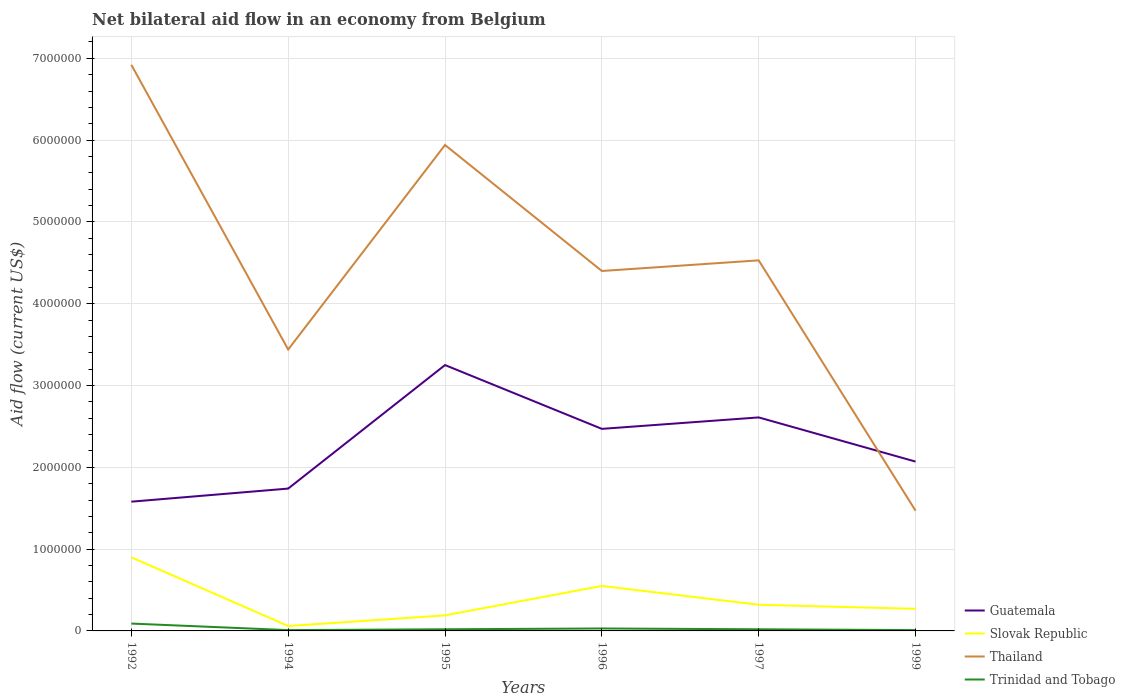How many different coloured lines are there?
Offer a very short reply. 4. Does the line corresponding to Thailand intersect with the line corresponding to Slovak Republic?
Ensure brevity in your answer.  No. Across all years, what is the maximum net bilateral aid flow in Guatemala?
Make the answer very short. 1.58e+06. What is the difference between the highest and the second highest net bilateral aid flow in Slovak Republic?
Your response must be concise. 8.40e+05. What is the difference between the highest and the lowest net bilateral aid flow in Slovak Republic?
Ensure brevity in your answer.  2. How many lines are there?
Your answer should be very brief. 4. How many years are there in the graph?
Provide a succinct answer. 6. What is the difference between two consecutive major ticks on the Y-axis?
Your response must be concise. 1.00e+06. Does the graph contain any zero values?
Your response must be concise. No. Does the graph contain grids?
Your answer should be very brief. Yes. How many legend labels are there?
Offer a very short reply. 4. What is the title of the graph?
Your answer should be very brief. Net bilateral aid flow in an economy from Belgium. What is the label or title of the Y-axis?
Provide a succinct answer. Aid flow (current US$). What is the Aid flow (current US$) of Guatemala in 1992?
Your answer should be very brief. 1.58e+06. What is the Aid flow (current US$) of Thailand in 1992?
Provide a short and direct response. 6.92e+06. What is the Aid flow (current US$) of Trinidad and Tobago in 1992?
Ensure brevity in your answer.  9.00e+04. What is the Aid flow (current US$) of Guatemala in 1994?
Offer a very short reply. 1.74e+06. What is the Aid flow (current US$) in Slovak Republic in 1994?
Ensure brevity in your answer.  6.00e+04. What is the Aid flow (current US$) in Thailand in 1994?
Offer a very short reply. 3.44e+06. What is the Aid flow (current US$) of Guatemala in 1995?
Provide a succinct answer. 3.25e+06. What is the Aid flow (current US$) in Thailand in 1995?
Offer a terse response. 5.94e+06. What is the Aid flow (current US$) of Trinidad and Tobago in 1995?
Make the answer very short. 2.00e+04. What is the Aid flow (current US$) in Guatemala in 1996?
Your response must be concise. 2.47e+06. What is the Aid flow (current US$) of Thailand in 1996?
Give a very brief answer. 4.40e+06. What is the Aid flow (current US$) of Guatemala in 1997?
Provide a succinct answer. 2.61e+06. What is the Aid flow (current US$) of Slovak Republic in 1997?
Ensure brevity in your answer.  3.20e+05. What is the Aid flow (current US$) in Thailand in 1997?
Make the answer very short. 4.53e+06. What is the Aid flow (current US$) of Guatemala in 1999?
Offer a terse response. 2.07e+06. What is the Aid flow (current US$) of Slovak Republic in 1999?
Offer a terse response. 2.70e+05. What is the Aid flow (current US$) in Thailand in 1999?
Your answer should be compact. 1.47e+06. What is the Aid flow (current US$) of Trinidad and Tobago in 1999?
Ensure brevity in your answer.  10000. Across all years, what is the maximum Aid flow (current US$) of Guatemala?
Keep it short and to the point. 3.25e+06. Across all years, what is the maximum Aid flow (current US$) of Slovak Republic?
Offer a terse response. 9.00e+05. Across all years, what is the maximum Aid flow (current US$) of Thailand?
Your answer should be compact. 6.92e+06. Across all years, what is the maximum Aid flow (current US$) in Trinidad and Tobago?
Offer a terse response. 9.00e+04. Across all years, what is the minimum Aid flow (current US$) in Guatemala?
Offer a very short reply. 1.58e+06. Across all years, what is the minimum Aid flow (current US$) in Slovak Republic?
Provide a succinct answer. 6.00e+04. Across all years, what is the minimum Aid flow (current US$) in Thailand?
Ensure brevity in your answer.  1.47e+06. What is the total Aid flow (current US$) in Guatemala in the graph?
Give a very brief answer. 1.37e+07. What is the total Aid flow (current US$) in Slovak Republic in the graph?
Make the answer very short. 2.29e+06. What is the total Aid flow (current US$) of Thailand in the graph?
Offer a terse response. 2.67e+07. What is the total Aid flow (current US$) in Trinidad and Tobago in the graph?
Offer a terse response. 1.80e+05. What is the difference between the Aid flow (current US$) in Guatemala in 1992 and that in 1994?
Your answer should be very brief. -1.60e+05. What is the difference between the Aid flow (current US$) of Slovak Republic in 1992 and that in 1994?
Provide a short and direct response. 8.40e+05. What is the difference between the Aid flow (current US$) in Thailand in 1992 and that in 1994?
Make the answer very short. 3.48e+06. What is the difference between the Aid flow (current US$) in Trinidad and Tobago in 1992 and that in 1994?
Your answer should be compact. 8.00e+04. What is the difference between the Aid flow (current US$) in Guatemala in 1992 and that in 1995?
Offer a very short reply. -1.67e+06. What is the difference between the Aid flow (current US$) in Slovak Republic in 1992 and that in 1995?
Offer a very short reply. 7.10e+05. What is the difference between the Aid flow (current US$) of Thailand in 1992 and that in 1995?
Keep it short and to the point. 9.80e+05. What is the difference between the Aid flow (current US$) in Guatemala in 1992 and that in 1996?
Ensure brevity in your answer.  -8.90e+05. What is the difference between the Aid flow (current US$) in Slovak Republic in 1992 and that in 1996?
Your answer should be very brief. 3.50e+05. What is the difference between the Aid flow (current US$) in Thailand in 1992 and that in 1996?
Ensure brevity in your answer.  2.52e+06. What is the difference between the Aid flow (current US$) of Guatemala in 1992 and that in 1997?
Offer a very short reply. -1.03e+06. What is the difference between the Aid flow (current US$) in Slovak Republic in 1992 and that in 1997?
Your response must be concise. 5.80e+05. What is the difference between the Aid flow (current US$) of Thailand in 1992 and that in 1997?
Offer a terse response. 2.39e+06. What is the difference between the Aid flow (current US$) in Trinidad and Tobago in 1992 and that in 1997?
Provide a succinct answer. 7.00e+04. What is the difference between the Aid flow (current US$) of Guatemala in 1992 and that in 1999?
Your response must be concise. -4.90e+05. What is the difference between the Aid flow (current US$) in Slovak Republic in 1992 and that in 1999?
Your response must be concise. 6.30e+05. What is the difference between the Aid flow (current US$) of Thailand in 1992 and that in 1999?
Make the answer very short. 5.45e+06. What is the difference between the Aid flow (current US$) in Guatemala in 1994 and that in 1995?
Make the answer very short. -1.51e+06. What is the difference between the Aid flow (current US$) in Thailand in 1994 and that in 1995?
Offer a very short reply. -2.50e+06. What is the difference between the Aid flow (current US$) in Guatemala in 1994 and that in 1996?
Your answer should be compact. -7.30e+05. What is the difference between the Aid flow (current US$) in Slovak Republic in 1994 and that in 1996?
Your response must be concise. -4.90e+05. What is the difference between the Aid flow (current US$) of Thailand in 1994 and that in 1996?
Give a very brief answer. -9.60e+05. What is the difference between the Aid flow (current US$) in Guatemala in 1994 and that in 1997?
Provide a succinct answer. -8.70e+05. What is the difference between the Aid flow (current US$) in Thailand in 1994 and that in 1997?
Give a very brief answer. -1.09e+06. What is the difference between the Aid flow (current US$) of Trinidad and Tobago in 1994 and that in 1997?
Keep it short and to the point. -10000. What is the difference between the Aid flow (current US$) of Guatemala in 1994 and that in 1999?
Keep it short and to the point. -3.30e+05. What is the difference between the Aid flow (current US$) in Slovak Republic in 1994 and that in 1999?
Provide a succinct answer. -2.10e+05. What is the difference between the Aid flow (current US$) of Thailand in 1994 and that in 1999?
Your answer should be compact. 1.97e+06. What is the difference between the Aid flow (current US$) in Trinidad and Tobago in 1994 and that in 1999?
Your answer should be compact. 0. What is the difference between the Aid flow (current US$) of Guatemala in 1995 and that in 1996?
Provide a short and direct response. 7.80e+05. What is the difference between the Aid flow (current US$) of Slovak Republic in 1995 and that in 1996?
Your answer should be very brief. -3.60e+05. What is the difference between the Aid flow (current US$) of Thailand in 1995 and that in 1996?
Your answer should be very brief. 1.54e+06. What is the difference between the Aid flow (current US$) of Guatemala in 1995 and that in 1997?
Provide a succinct answer. 6.40e+05. What is the difference between the Aid flow (current US$) of Thailand in 1995 and that in 1997?
Keep it short and to the point. 1.41e+06. What is the difference between the Aid flow (current US$) in Trinidad and Tobago in 1995 and that in 1997?
Your response must be concise. 0. What is the difference between the Aid flow (current US$) in Guatemala in 1995 and that in 1999?
Your answer should be very brief. 1.18e+06. What is the difference between the Aid flow (current US$) of Thailand in 1995 and that in 1999?
Provide a succinct answer. 4.47e+06. What is the difference between the Aid flow (current US$) in Guatemala in 1996 and that in 1997?
Give a very brief answer. -1.40e+05. What is the difference between the Aid flow (current US$) in Trinidad and Tobago in 1996 and that in 1997?
Your response must be concise. 10000. What is the difference between the Aid flow (current US$) in Guatemala in 1996 and that in 1999?
Provide a succinct answer. 4.00e+05. What is the difference between the Aid flow (current US$) of Slovak Republic in 1996 and that in 1999?
Provide a succinct answer. 2.80e+05. What is the difference between the Aid flow (current US$) of Thailand in 1996 and that in 1999?
Keep it short and to the point. 2.93e+06. What is the difference between the Aid flow (current US$) of Guatemala in 1997 and that in 1999?
Your answer should be very brief. 5.40e+05. What is the difference between the Aid flow (current US$) of Thailand in 1997 and that in 1999?
Provide a succinct answer. 3.06e+06. What is the difference between the Aid flow (current US$) of Guatemala in 1992 and the Aid flow (current US$) of Slovak Republic in 1994?
Your answer should be compact. 1.52e+06. What is the difference between the Aid flow (current US$) of Guatemala in 1992 and the Aid flow (current US$) of Thailand in 1994?
Make the answer very short. -1.86e+06. What is the difference between the Aid flow (current US$) of Guatemala in 1992 and the Aid flow (current US$) of Trinidad and Tobago in 1994?
Keep it short and to the point. 1.57e+06. What is the difference between the Aid flow (current US$) in Slovak Republic in 1992 and the Aid flow (current US$) in Thailand in 1994?
Keep it short and to the point. -2.54e+06. What is the difference between the Aid flow (current US$) of Slovak Republic in 1992 and the Aid flow (current US$) of Trinidad and Tobago in 1994?
Offer a terse response. 8.90e+05. What is the difference between the Aid flow (current US$) in Thailand in 1992 and the Aid flow (current US$) in Trinidad and Tobago in 1994?
Ensure brevity in your answer.  6.91e+06. What is the difference between the Aid flow (current US$) in Guatemala in 1992 and the Aid flow (current US$) in Slovak Republic in 1995?
Ensure brevity in your answer.  1.39e+06. What is the difference between the Aid flow (current US$) of Guatemala in 1992 and the Aid flow (current US$) of Thailand in 1995?
Keep it short and to the point. -4.36e+06. What is the difference between the Aid flow (current US$) of Guatemala in 1992 and the Aid flow (current US$) of Trinidad and Tobago in 1995?
Offer a very short reply. 1.56e+06. What is the difference between the Aid flow (current US$) of Slovak Republic in 1992 and the Aid flow (current US$) of Thailand in 1995?
Provide a succinct answer. -5.04e+06. What is the difference between the Aid flow (current US$) in Slovak Republic in 1992 and the Aid flow (current US$) in Trinidad and Tobago in 1995?
Provide a short and direct response. 8.80e+05. What is the difference between the Aid flow (current US$) of Thailand in 1992 and the Aid flow (current US$) of Trinidad and Tobago in 1995?
Offer a terse response. 6.90e+06. What is the difference between the Aid flow (current US$) in Guatemala in 1992 and the Aid flow (current US$) in Slovak Republic in 1996?
Provide a short and direct response. 1.03e+06. What is the difference between the Aid flow (current US$) of Guatemala in 1992 and the Aid flow (current US$) of Thailand in 1996?
Offer a very short reply. -2.82e+06. What is the difference between the Aid flow (current US$) of Guatemala in 1992 and the Aid flow (current US$) of Trinidad and Tobago in 1996?
Offer a terse response. 1.55e+06. What is the difference between the Aid flow (current US$) of Slovak Republic in 1992 and the Aid flow (current US$) of Thailand in 1996?
Your answer should be compact. -3.50e+06. What is the difference between the Aid flow (current US$) in Slovak Republic in 1992 and the Aid flow (current US$) in Trinidad and Tobago in 1996?
Your response must be concise. 8.70e+05. What is the difference between the Aid flow (current US$) in Thailand in 1992 and the Aid flow (current US$) in Trinidad and Tobago in 1996?
Your answer should be compact. 6.89e+06. What is the difference between the Aid flow (current US$) in Guatemala in 1992 and the Aid flow (current US$) in Slovak Republic in 1997?
Offer a very short reply. 1.26e+06. What is the difference between the Aid flow (current US$) of Guatemala in 1992 and the Aid flow (current US$) of Thailand in 1997?
Make the answer very short. -2.95e+06. What is the difference between the Aid flow (current US$) of Guatemala in 1992 and the Aid flow (current US$) of Trinidad and Tobago in 1997?
Make the answer very short. 1.56e+06. What is the difference between the Aid flow (current US$) of Slovak Republic in 1992 and the Aid flow (current US$) of Thailand in 1997?
Offer a terse response. -3.63e+06. What is the difference between the Aid flow (current US$) of Slovak Republic in 1992 and the Aid flow (current US$) of Trinidad and Tobago in 1997?
Keep it short and to the point. 8.80e+05. What is the difference between the Aid flow (current US$) in Thailand in 1992 and the Aid flow (current US$) in Trinidad and Tobago in 1997?
Provide a succinct answer. 6.90e+06. What is the difference between the Aid flow (current US$) of Guatemala in 1992 and the Aid flow (current US$) of Slovak Republic in 1999?
Your answer should be compact. 1.31e+06. What is the difference between the Aid flow (current US$) of Guatemala in 1992 and the Aid flow (current US$) of Thailand in 1999?
Offer a terse response. 1.10e+05. What is the difference between the Aid flow (current US$) of Guatemala in 1992 and the Aid flow (current US$) of Trinidad and Tobago in 1999?
Offer a very short reply. 1.57e+06. What is the difference between the Aid flow (current US$) of Slovak Republic in 1992 and the Aid flow (current US$) of Thailand in 1999?
Provide a short and direct response. -5.70e+05. What is the difference between the Aid flow (current US$) in Slovak Republic in 1992 and the Aid flow (current US$) in Trinidad and Tobago in 1999?
Your response must be concise. 8.90e+05. What is the difference between the Aid flow (current US$) in Thailand in 1992 and the Aid flow (current US$) in Trinidad and Tobago in 1999?
Your answer should be compact. 6.91e+06. What is the difference between the Aid flow (current US$) in Guatemala in 1994 and the Aid flow (current US$) in Slovak Republic in 1995?
Your answer should be compact. 1.55e+06. What is the difference between the Aid flow (current US$) in Guatemala in 1994 and the Aid flow (current US$) in Thailand in 1995?
Your answer should be compact. -4.20e+06. What is the difference between the Aid flow (current US$) in Guatemala in 1994 and the Aid flow (current US$) in Trinidad and Tobago in 1995?
Make the answer very short. 1.72e+06. What is the difference between the Aid flow (current US$) in Slovak Republic in 1994 and the Aid flow (current US$) in Thailand in 1995?
Provide a succinct answer. -5.88e+06. What is the difference between the Aid flow (current US$) in Slovak Republic in 1994 and the Aid flow (current US$) in Trinidad and Tobago in 1995?
Offer a very short reply. 4.00e+04. What is the difference between the Aid flow (current US$) of Thailand in 1994 and the Aid flow (current US$) of Trinidad and Tobago in 1995?
Provide a short and direct response. 3.42e+06. What is the difference between the Aid flow (current US$) in Guatemala in 1994 and the Aid flow (current US$) in Slovak Republic in 1996?
Your response must be concise. 1.19e+06. What is the difference between the Aid flow (current US$) of Guatemala in 1994 and the Aid flow (current US$) of Thailand in 1996?
Provide a short and direct response. -2.66e+06. What is the difference between the Aid flow (current US$) of Guatemala in 1994 and the Aid flow (current US$) of Trinidad and Tobago in 1996?
Offer a very short reply. 1.71e+06. What is the difference between the Aid flow (current US$) of Slovak Republic in 1994 and the Aid flow (current US$) of Thailand in 1996?
Make the answer very short. -4.34e+06. What is the difference between the Aid flow (current US$) of Slovak Republic in 1994 and the Aid flow (current US$) of Trinidad and Tobago in 1996?
Keep it short and to the point. 3.00e+04. What is the difference between the Aid flow (current US$) of Thailand in 1994 and the Aid flow (current US$) of Trinidad and Tobago in 1996?
Keep it short and to the point. 3.41e+06. What is the difference between the Aid flow (current US$) of Guatemala in 1994 and the Aid flow (current US$) of Slovak Republic in 1997?
Keep it short and to the point. 1.42e+06. What is the difference between the Aid flow (current US$) in Guatemala in 1994 and the Aid flow (current US$) in Thailand in 1997?
Your response must be concise. -2.79e+06. What is the difference between the Aid flow (current US$) of Guatemala in 1994 and the Aid flow (current US$) of Trinidad and Tobago in 1997?
Ensure brevity in your answer.  1.72e+06. What is the difference between the Aid flow (current US$) of Slovak Republic in 1994 and the Aid flow (current US$) of Thailand in 1997?
Make the answer very short. -4.47e+06. What is the difference between the Aid flow (current US$) in Slovak Republic in 1994 and the Aid flow (current US$) in Trinidad and Tobago in 1997?
Ensure brevity in your answer.  4.00e+04. What is the difference between the Aid flow (current US$) in Thailand in 1994 and the Aid flow (current US$) in Trinidad and Tobago in 1997?
Provide a succinct answer. 3.42e+06. What is the difference between the Aid flow (current US$) in Guatemala in 1994 and the Aid flow (current US$) in Slovak Republic in 1999?
Ensure brevity in your answer.  1.47e+06. What is the difference between the Aid flow (current US$) of Guatemala in 1994 and the Aid flow (current US$) of Thailand in 1999?
Your answer should be compact. 2.70e+05. What is the difference between the Aid flow (current US$) in Guatemala in 1994 and the Aid flow (current US$) in Trinidad and Tobago in 1999?
Give a very brief answer. 1.73e+06. What is the difference between the Aid flow (current US$) in Slovak Republic in 1994 and the Aid flow (current US$) in Thailand in 1999?
Make the answer very short. -1.41e+06. What is the difference between the Aid flow (current US$) of Slovak Republic in 1994 and the Aid flow (current US$) of Trinidad and Tobago in 1999?
Your answer should be very brief. 5.00e+04. What is the difference between the Aid flow (current US$) in Thailand in 1994 and the Aid flow (current US$) in Trinidad and Tobago in 1999?
Provide a short and direct response. 3.43e+06. What is the difference between the Aid flow (current US$) of Guatemala in 1995 and the Aid flow (current US$) of Slovak Republic in 1996?
Give a very brief answer. 2.70e+06. What is the difference between the Aid flow (current US$) in Guatemala in 1995 and the Aid flow (current US$) in Thailand in 1996?
Give a very brief answer. -1.15e+06. What is the difference between the Aid flow (current US$) in Guatemala in 1995 and the Aid flow (current US$) in Trinidad and Tobago in 1996?
Ensure brevity in your answer.  3.22e+06. What is the difference between the Aid flow (current US$) of Slovak Republic in 1995 and the Aid flow (current US$) of Thailand in 1996?
Your answer should be compact. -4.21e+06. What is the difference between the Aid flow (current US$) in Slovak Republic in 1995 and the Aid flow (current US$) in Trinidad and Tobago in 1996?
Provide a succinct answer. 1.60e+05. What is the difference between the Aid flow (current US$) in Thailand in 1995 and the Aid flow (current US$) in Trinidad and Tobago in 1996?
Offer a terse response. 5.91e+06. What is the difference between the Aid flow (current US$) of Guatemala in 1995 and the Aid flow (current US$) of Slovak Republic in 1997?
Keep it short and to the point. 2.93e+06. What is the difference between the Aid flow (current US$) of Guatemala in 1995 and the Aid flow (current US$) of Thailand in 1997?
Your response must be concise. -1.28e+06. What is the difference between the Aid flow (current US$) of Guatemala in 1995 and the Aid flow (current US$) of Trinidad and Tobago in 1997?
Give a very brief answer. 3.23e+06. What is the difference between the Aid flow (current US$) of Slovak Republic in 1995 and the Aid flow (current US$) of Thailand in 1997?
Offer a very short reply. -4.34e+06. What is the difference between the Aid flow (current US$) in Slovak Republic in 1995 and the Aid flow (current US$) in Trinidad and Tobago in 1997?
Make the answer very short. 1.70e+05. What is the difference between the Aid flow (current US$) of Thailand in 1995 and the Aid flow (current US$) of Trinidad and Tobago in 1997?
Your response must be concise. 5.92e+06. What is the difference between the Aid flow (current US$) in Guatemala in 1995 and the Aid flow (current US$) in Slovak Republic in 1999?
Your answer should be compact. 2.98e+06. What is the difference between the Aid flow (current US$) in Guatemala in 1995 and the Aid flow (current US$) in Thailand in 1999?
Provide a short and direct response. 1.78e+06. What is the difference between the Aid flow (current US$) in Guatemala in 1995 and the Aid flow (current US$) in Trinidad and Tobago in 1999?
Offer a terse response. 3.24e+06. What is the difference between the Aid flow (current US$) of Slovak Republic in 1995 and the Aid flow (current US$) of Thailand in 1999?
Offer a terse response. -1.28e+06. What is the difference between the Aid flow (current US$) in Thailand in 1995 and the Aid flow (current US$) in Trinidad and Tobago in 1999?
Offer a terse response. 5.93e+06. What is the difference between the Aid flow (current US$) in Guatemala in 1996 and the Aid flow (current US$) in Slovak Republic in 1997?
Provide a short and direct response. 2.15e+06. What is the difference between the Aid flow (current US$) of Guatemala in 1996 and the Aid flow (current US$) of Thailand in 1997?
Offer a terse response. -2.06e+06. What is the difference between the Aid flow (current US$) in Guatemala in 1996 and the Aid flow (current US$) in Trinidad and Tobago in 1997?
Make the answer very short. 2.45e+06. What is the difference between the Aid flow (current US$) of Slovak Republic in 1996 and the Aid flow (current US$) of Thailand in 1997?
Your answer should be very brief. -3.98e+06. What is the difference between the Aid flow (current US$) of Slovak Republic in 1996 and the Aid flow (current US$) of Trinidad and Tobago in 1997?
Your answer should be very brief. 5.30e+05. What is the difference between the Aid flow (current US$) in Thailand in 1996 and the Aid flow (current US$) in Trinidad and Tobago in 1997?
Make the answer very short. 4.38e+06. What is the difference between the Aid flow (current US$) in Guatemala in 1996 and the Aid flow (current US$) in Slovak Republic in 1999?
Your answer should be very brief. 2.20e+06. What is the difference between the Aid flow (current US$) in Guatemala in 1996 and the Aid flow (current US$) in Trinidad and Tobago in 1999?
Provide a short and direct response. 2.46e+06. What is the difference between the Aid flow (current US$) in Slovak Republic in 1996 and the Aid flow (current US$) in Thailand in 1999?
Keep it short and to the point. -9.20e+05. What is the difference between the Aid flow (current US$) of Slovak Republic in 1996 and the Aid flow (current US$) of Trinidad and Tobago in 1999?
Keep it short and to the point. 5.40e+05. What is the difference between the Aid flow (current US$) of Thailand in 1996 and the Aid flow (current US$) of Trinidad and Tobago in 1999?
Make the answer very short. 4.39e+06. What is the difference between the Aid flow (current US$) in Guatemala in 1997 and the Aid flow (current US$) in Slovak Republic in 1999?
Your answer should be compact. 2.34e+06. What is the difference between the Aid flow (current US$) in Guatemala in 1997 and the Aid flow (current US$) in Thailand in 1999?
Ensure brevity in your answer.  1.14e+06. What is the difference between the Aid flow (current US$) of Guatemala in 1997 and the Aid flow (current US$) of Trinidad and Tobago in 1999?
Offer a terse response. 2.60e+06. What is the difference between the Aid flow (current US$) of Slovak Republic in 1997 and the Aid flow (current US$) of Thailand in 1999?
Give a very brief answer. -1.15e+06. What is the difference between the Aid flow (current US$) of Thailand in 1997 and the Aid flow (current US$) of Trinidad and Tobago in 1999?
Make the answer very short. 4.52e+06. What is the average Aid flow (current US$) in Guatemala per year?
Your answer should be compact. 2.29e+06. What is the average Aid flow (current US$) of Slovak Republic per year?
Your answer should be compact. 3.82e+05. What is the average Aid flow (current US$) of Thailand per year?
Your answer should be compact. 4.45e+06. In the year 1992, what is the difference between the Aid flow (current US$) in Guatemala and Aid flow (current US$) in Slovak Republic?
Your answer should be compact. 6.80e+05. In the year 1992, what is the difference between the Aid flow (current US$) in Guatemala and Aid flow (current US$) in Thailand?
Keep it short and to the point. -5.34e+06. In the year 1992, what is the difference between the Aid flow (current US$) of Guatemala and Aid flow (current US$) of Trinidad and Tobago?
Make the answer very short. 1.49e+06. In the year 1992, what is the difference between the Aid flow (current US$) in Slovak Republic and Aid flow (current US$) in Thailand?
Offer a very short reply. -6.02e+06. In the year 1992, what is the difference between the Aid flow (current US$) in Slovak Republic and Aid flow (current US$) in Trinidad and Tobago?
Offer a terse response. 8.10e+05. In the year 1992, what is the difference between the Aid flow (current US$) of Thailand and Aid flow (current US$) of Trinidad and Tobago?
Your answer should be very brief. 6.83e+06. In the year 1994, what is the difference between the Aid flow (current US$) of Guatemala and Aid flow (current US$) of Slovak Republic?
Your answer should be very brief. 1.68e+06. In the year 1994, what is the difference between the Aid flow (current US$) of Guatemala and Aid flow (current US$) of Thailand?
Provide a short and direct response. -1.70e+06. In the year 1994, what is the difference between the Aid flow (current US$) in Guatemala and Aid flow (current US$) in Trinidad and Tobago?
Make the answer very short. 1.73e+06. In the year 1994, what is the difference between the Aid flow (current US$) in Slovak Republic and Aid flow (current US$) in Thailand?
Your response must be concise. -3.38e+06. In the year 1994, what is the difference between the Aid flow (current US$) in Slovak Republic and Aid flow (current US$) in Trinidad and Tobago?
Ensure brevity in your answer.  5.00e+04. In the year 1994, what is the difference between the Aid flow (current US$) in Thailand and Aid flow (current US$) in Trinidad and Tobago?
Provide a short and direct response. 3.43e+06. In the year 1995, what is the difference between the Aid flow (current US$) in Guatemala and Aid flow (current US$) in Slovak Republic?
Provide a succinct answer. 3.06e+06. In the year 1995, what is the difference between the Aid flow (current US$) in Guatemala and Aid flow (current US$) in Thailand?
Offer a very short reply. -2.69e+06. In the year 1995, what is the difference between the Aid flow (current US$) of Guatemala and Aid flow (current US$) of Trinidad and Tobago?
Offer a terse response. 3.23e+06. In the year 1995, what is the difference between the Aid flow (current US$) in Slovak Republic and Aid flow (current US$) in Thailand?
Keep it short and to the point. -5.75e+06. In the year 1995, what is the difference between the Aid flow (current US$) of Thailand and Aid flow (current US$) of Trinidad and Tobago?
Ensure brevity in your answer.  5.92e+06. In the year 1996, what is the difference between the Aid flow (current US$) in Guatemala and Aid flow (current US$) in Slovak Republic?
Offer a terse response. 1.92e+06. In the year 1996, what is the difference between the Aid flow (current US$) in Guatemala and Aid flow (current US$) in Thailand?
Make the answer very short. -1.93e+06. In the year 1996, what is the difference between the Aid flow (current US$) in Guatemala and Aid flow (current US$) in Trinidad and Tobago?
Keep it short and to the point. 2.44e+06. In the year 1996, what is the difference between the Aid flow (current US$) of Slovak Republic and Aid flow (current US$) of Thailand?
Your answer should be very brief. -3.85e+06. In the year 1996, what is the difference between the Aid flow (current US$) of Slovak Republic and Aid flow (current US$) of Trinidad and Tobago?
Ensure brevity in your answer.  5.20e+05. In the year 1996, what is the difference between the Aid flow (current US$) in Thailand and Aid flow (current US$) in Trinidad and Tobago?
Ensure brevity in your answer.  4.37e+06. In the year 1997, what is the difference between the Aid flow (current US$) of Guatemala and Aid flow (current US$) of Slovak Republic?
Provide a short and direct response. 2.29e+06. In the year 1997, what is the difference between the Aid flow (current US$) in Guatemala and Aid flow (current US$) in Thailand?
Give a very brief answer. -1.92e+06. In the year 1997, what is the difference between the Aid flow (current US$) in Guatemala and Aid flow (current US$) in Trinidad and Tobago?
Offer a very short reply. 2.59e+06. In the year 1997, what is the difference between the Aid flow (current US$) in Slovak Republic and Aid flow (current US$) in Thailand?
Your answer should be compact. -4.21e+06. In the year 1997, what is the difference between the Aid flow (current US$) in Thailand and Aid flow (current US$) in Trinidad and Tobago?
Your response must be concise. 4.51e+06. In the year 1999, what is the difference between the Aid flow (current US$) of Guatemala and Aid flow (current US$) of Slovak Republic?
Ensure brevity in your answer.  1.80e+06. In the year 1999, what is the difference between the Aid flow (current US$) of Guatemala and Aid flow (current US$) of Thailand?
Your response must be concise. 6.00e+05. In the year 1999, what is the difference between the Aid flow (current US$) of Guatemala and Aid flow (current US$) of Trinidad and Tobago?
Your answer should be very brief. 2.06e+06. In the year 1999, what is the difference between the Aid flow (current US$) in Slovak Republic and Aid flow (current US$) in Thailand?
Ensure brevity in your answer.  -1.20e+06. In the year 1999, what is the difference between the Aid flow (current US$) in Thailand and Aid flow (current US$) in Trinidad and Tobago?
Your response must be concise. 1.46e+06. What is the ratio of the Aid flow (current US$) of Guatemala in 1992 to that in 1994?
Your response must be concise. 0.91. What is the ratio of the Aid flow (current US$) in Slovak Republic in 1992 to that in 1994?
Your answer should be compact. 15. What is the ratio of the Aid flow (current US$) of Thailand in 1992 to that in 1994?
Provide a succinct answer. 2.01. What is the ratio of the Aid flow (current US$) in Guatemala in 1992 to that in 1995?
Offer a very short reply. 0.49. What is the ratio of the Aid flow (current US$) of Slovak Republic in 1992 to that in 1995?
Ensure brevity in your answer.  4.74. What is the ratio of the Aid flow (current US$) of Thailand in 1992 to that in 1995?
Offer a terse response. 1.17. What is the ratio of the Aid flow (current US$) of Guatemala in 1992 to that in 1996?
Your answer should be very brief. 0.64. What is the ratio of the Aid flow (current US$) of Slovak Republic in 1992 to that in 1996?
Provide a succinct answer. 1.64. What is the ratio of the Aid flow (current US$) of Thailand in 1992 to that in 1996?
Make the answer very short. 1.57. What is the ratio of the Aid flow (current US$) in Guatemala in 1992 to that in 1997?
Keep it short and to the point. 0.61. What is the ratio of the Aid flow (current US$) in Slovak Republic in 1992 to that in 1997?
Make the answer very short. 2.81. What is the ratio of the Aid flow (current US$) in Thailand in 1992 to that in 1997?
Offer a terse response. 1.53. What is the ratio of the Aid flow (current US$) of Guatemala in 1992 to that in 1999?
Provide a short and direct response. 0.76. What is the ratio of the Aid flow (current US$) in Slovak Republic in 1992 to that in 1999?
Give a very brief answer. 3.33. What is the ratio of the Aid flow (current US$) of Thailand in 1992 to that in 1999?
Keep it short and to the point. 4.71. What is the ratio of the Aid flow (current US$) in Trinidad and Tobago in 1992 to that in 1999?
Keep it short and to the point. 9. What is the ratio of the Aid flow (current US$) of Guatemala in 1994 to that in 1995?
Offer a very short reply. 0.54. What is the ratio of the Aid flow (current US$) of Slovak Republic in 1994 to that in 1995?
Offer a terse response. 0.32. What is the ratio of the Aid flow (current US$) of Thailand in 1994 to that in 1995?
Offer a very short reply. 0.58. What is the ratio of the Aid flow (current US$) of Guatemala in 1994 to that in 1996?
Offer a terse response. 0.7. What is the ratio of the Aid flow (current US$) in Slovak Republic in 1994 to that in 1996?
Your response must be concise. 0.11. What is the ratio of the Aid flow (current US$) of Thailand in 1994 to that in 1996?
Your response must be concise. 0.78. What is the ratio of the Aid flow (current US$) of Trinidad and Tobago in 1994 to that in 1996?
Ensure brevity in your answer.  0.33. What is the ratio of the Aid flow (current US$) of Guatemala in 1994 to that in 1997?
Offer a very short reply. 0.67. What is the ratio of the Aid flow (current US$) of Slovak Republic in 1994 to that in 1997?
Offer a terse response. 0.19. What is the ratio of the Aid flow (current US$) of Thailand in 1994 to that in 1997?
Keep it short and to the point. 0.76. What is the ratio of the Aid flow (current US$) in Guatemala in 1994 to that in 1999?
Your response must be concise. 0.84. What is the ratio of the Aid flow (current US$) of Slovak Republic in 1994 to that in 1999?
Keep it short and to the point. 0.22. What is the ratio of the Aid flow (current US$) of Thailand in 1994 to that in 1999?
Offer a terse response. 2.34. What is the ratio of the Aid flow (current US$) of Guatemala in 1995 to that in 1996?
Give a very brief answer. 1.32. What is the ratio of the Aid flow (current US$) in Slovak Republic in 1995 to that in 1996?
Provide a short and direct response. 0.35. What is the ratio of the Aid flow (current US$) of Thailand in 1995 to that in 1996?
Offer a very short reply. 1.35. What is the ratio of the Aid flow (current US$) of Guatemala in 1995 to that in 1997?
Provide a succinct answer. 1.25. What is the ratio of the Aid flow (current US$) in Slovak Republic in 1995 to that in 1997?
Your answer should be very brief. 0.59. What is the ratio of the Aid flow (current US$) of Thailand in 1995 to that in 1997?
Give a very brief answer. 1.31. What is the ratio of the Aid flow (current US$) in Guatemala in 1995 to that in 1999?
Provide a succinct answer. 1.57. What is the ratio of the Aid flow (current US$) of Slovak Republic in 1995 to that in 1999?
Make the answer very short. 0.7. What is the ratio of the Aid flow (current US$) of Thailand in 1995 to that in 1999?
Provide a short and direct response. 4.04. What is the ratio of the Aid flow (current US$) in Guatemala in 1996 to that in 1997?
Provide a short and direct response. 0.95. What is the ratio of the Aid flow (current US$) in Slovak Republic in 1996 to that in 1997?
Offer a very short reply. 1.72. What is the ratio of the Aid flow (current US$) in Thailand in 1996 to that in 1997?
Make the answer very short. 0.97. What is the ratio of the Aid flow (current US$) in Guatemala in 1996 to that in 1999?
Provide a short and direct response. 1.19. What is the ratio of the Aid flow (current US$) of Slovak Republic in 1996 to that in 1999?
Give a very brief answer. 2.04. What is the ratio of the Aid flow (current US$) of Thailand in 1996 to that in 1999?
Give a very brief answer. 2.99. What is the ratio of the Aid flow (current US$) in Trinidad and Tobago in 1996 to that in 1999?
Make the answer very short. 3. What is the ratio of the Aid flow (current US$) in Guatemala in 1997 to that in 1999?
Keep it short and to the point. 1.26. What is the ratio of the Aid flow (current US$) in Slovak Republic in 1997 to that in 1999?
Give a very brief answer. 1.19. What is the ratio of the Aid flow (current US$) in Thailand in 1997 to that in 1999?
Make the answer very short. 3.08. What is the ratio of the Aid flow (current US$) of Trinidad and Tobago in 1997 to that in 1999?
Keep it short and to the point. 2. What is the difference between the highest and the second highest Aid flow (current US$) of Guatemala?
Provide a succinct answer. 6.40e+05. What is the difference between the highest and the second highest Aid flow (current US$) in Slovak Republic?
Your response must be concise. 3.50e+05. What is the difference between the highest and the second highest Aid flow (current US$) in Thailand?
Offer a very short reply. 9.80e+05. What is the difference between the highest and the lowest Aid flow (current US$) in Guatemala?
Your answer should be very brief. 1.67e+06. What is the difference between the highest and the lowest Aid flow (current US$) of Slovak Republic?
Your answer should be compact. 8.40e+05. What is the difference between the highest and the lowest Aid flow (current US$) in Thailand?
Keep it short and to the point. 5.45e+06. What is the difference between the highest and the lowest Aid flow (current US$) of Trinidad and Tobago?
Give a very brief answer. 8.00e+04. 